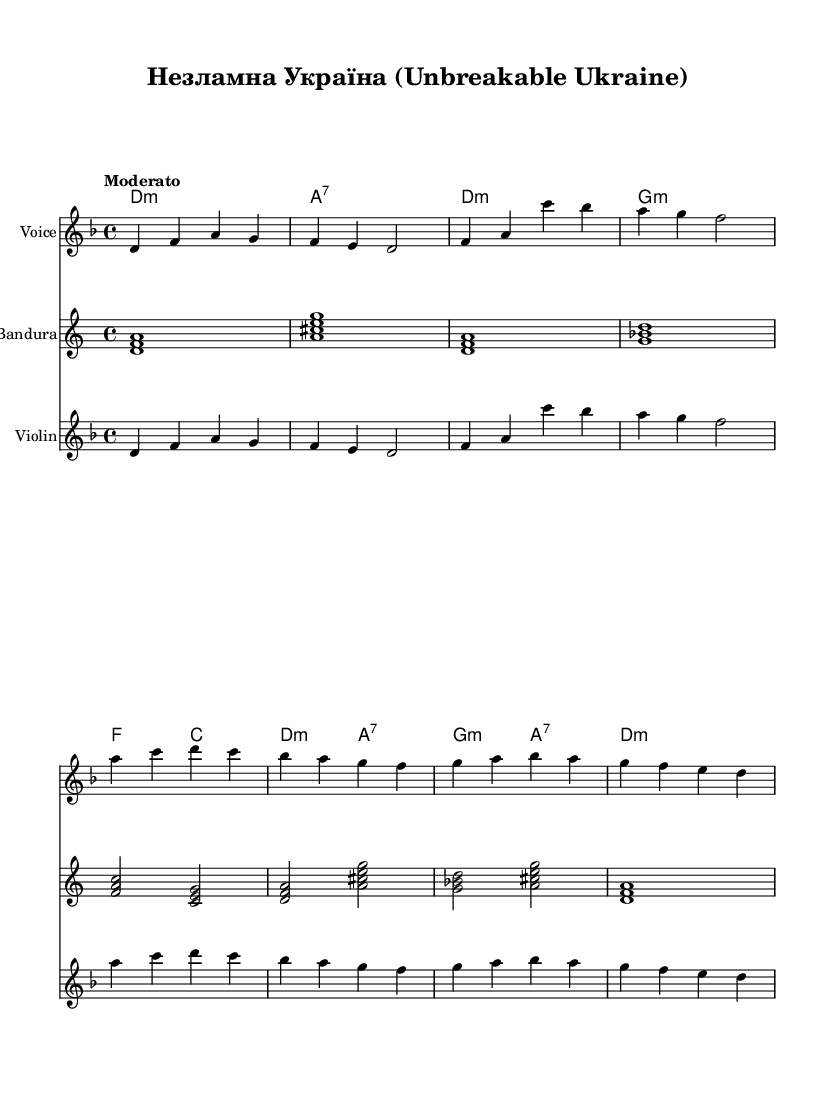What is the key signature of this music? The key signature is D minor, indicated by one flat (B flat) on the staff.
Answer: D minor What is the time signature of this piece? The time signature is 4/4, represented by the numbers at the beginning of the music section. This means there are four beats per measure.
Answer: 4/4 What is the tempo marking for this piece? The tempo marking is "Moderato," which indicates a moderate speed for the performance.
Answer: Moderato How many measures are in the melody part? The melody part consists of eight measures, as counted from the beginning to the end of the provided notes.
Answer: Eight What is the first note of the melody? The first note of the melody is D, which is the starting note of the relative pitch notation.
Answer: D Which harmonic structure is used at the end of the piece? The harmonic structure at the end is D minor, indicating a resolution back to the tonic chord that signifies the ending of the piece.
Answer: D minor 